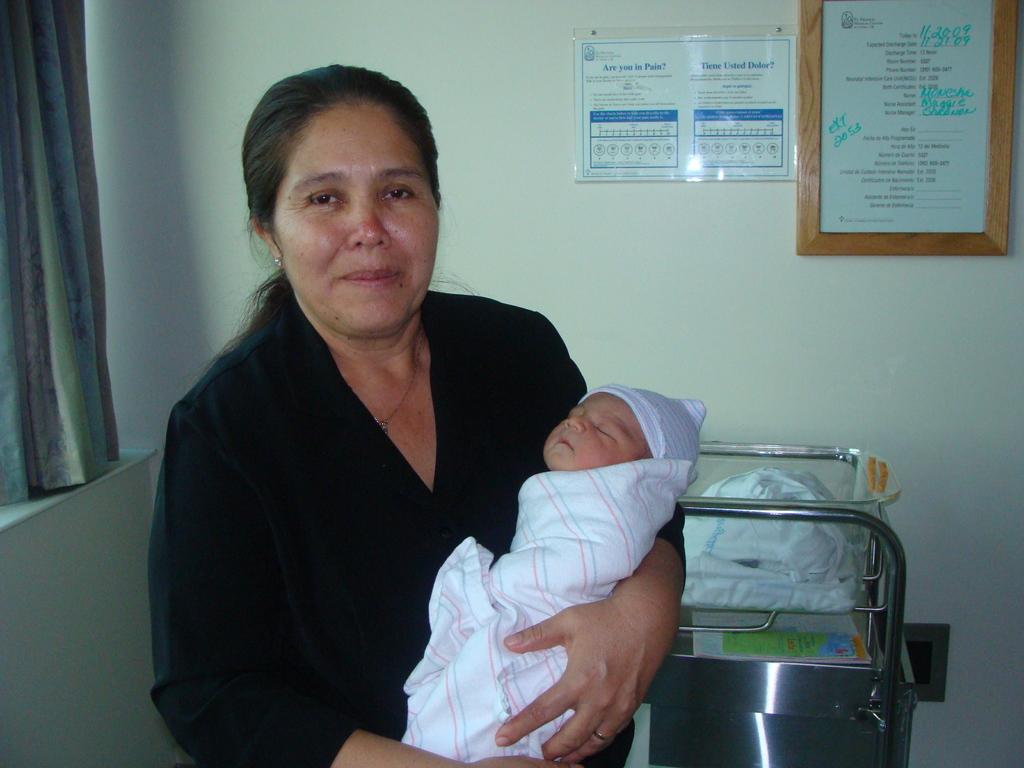What phone number extension is written in green marker on the board?
Provide a succinct answer. 2053. 